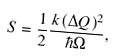Convert formula to latex. <formula><loc_0><loc_0><loc_500><loc_500>S = \frac { 1 } { 2 } \frac { k ( \Delta Q ) ^ { 2 } } { \hbar { \Omega } } ,</formula> 